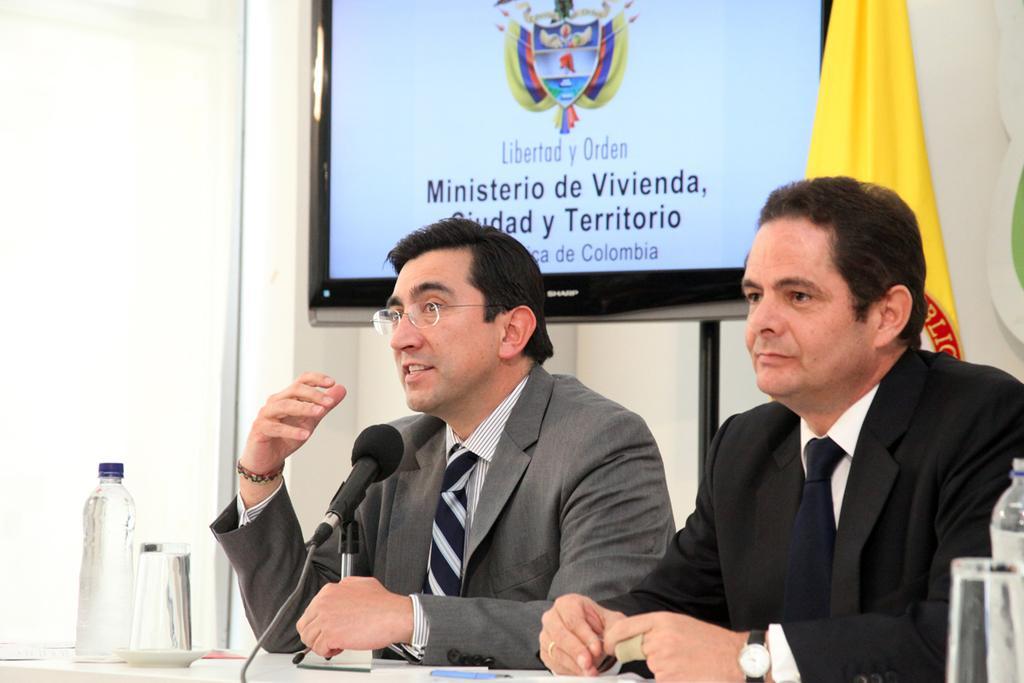How would you summarize this image in a sentence or two? In this image left side person is talking in the mike and the right side person is sitting on the chair. On the table there are two water bottles, two glasses and one pen. At the back side there is a TV and beside the TV there is a flag. 